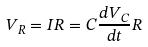<formula> <loc_0><loc_0><loc_500><loc_500>V _ { R } = I R = C \frac { d V _ { C } } { d t } R</formula> 